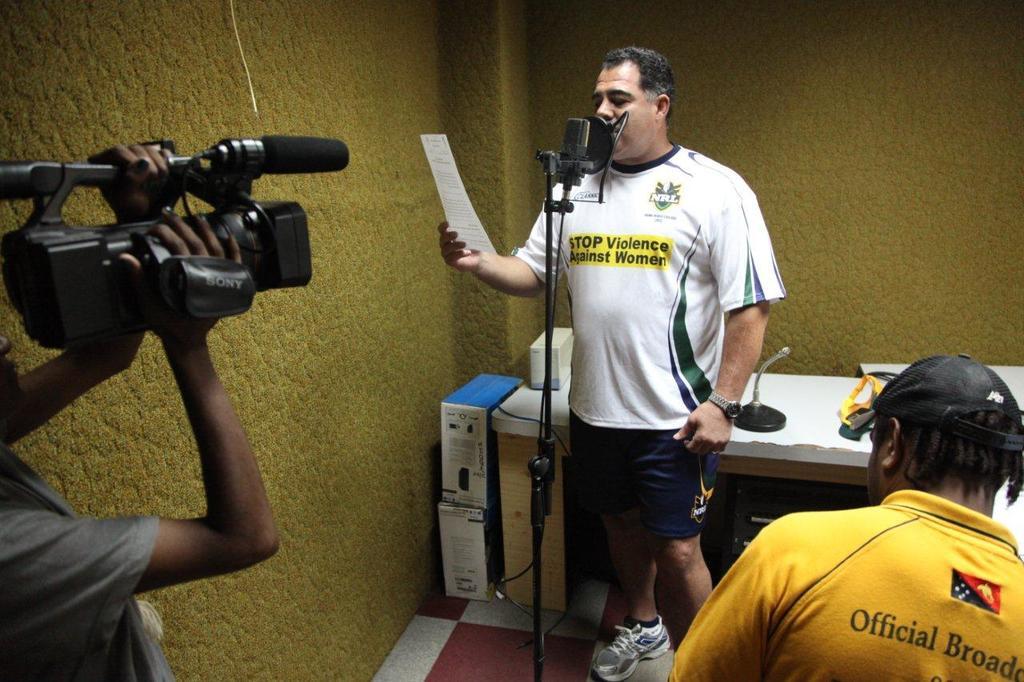What does it say on yellow shirt?
Ensure brevity in your answer.  Stop violence against women. 